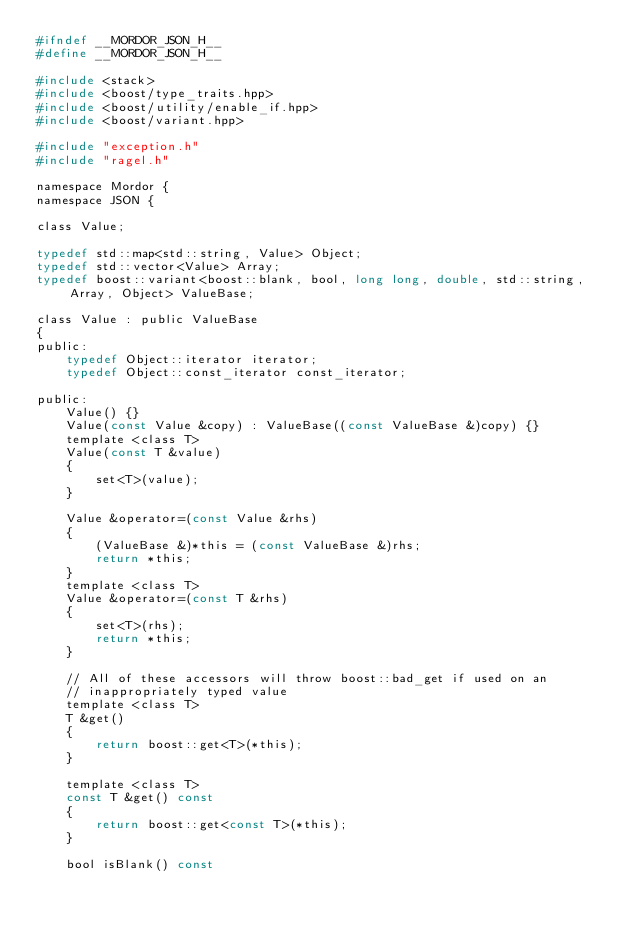<code> <loc_0><loc_0><loc_500><loc_500><_C_>#ifndef __MORDOR_JSON_H__
#define __MORDOR_JSON_H__

#include <stack>
#include <boost/type_traits.hpp>
#include <boost/utility/enable_if.hpp>
#include <boost/variant.hpp>

#include "exception.h"
#include "ragel.h"

namespace Mordor {
namespace JSON {

class Value;

typedef std::map<std::string, Value> Object;
typedef std::vector<Value> Array;
typedef boost::variant<boost::blank, bool, long long, double, std::string, Array, Object> ValueBase;

class Value : public ValueBase
{
public:
    typedef Object::iterator iterator;
    typedef Object::const_iterator const_iterator;

public:
    Value() {}
    Value(const Value &copy) : ValueBase((const ValueBase &)copy) {}
    template <class T>
    Value(const T &value)
    {
        set<T>(value);
    }

    Value &operator=(const Value &rhs)
    {
        (ValueBase &)*this = (const ValueBase &)rhs;
        return *this;
    }
    template <class T>
    Value &operator=(const T &rhs)
    {
        set<T>(rhs);
        return *this;
    }

    // All of these accessors will throw boost::bad_get if used on an
    // inappropriately typed value
    template <class T>
    T &get()
    {
        return boost::get<T>(*this);
    }

    template <class T>
    const T &get() const
    {
        return boost::get<const T>(*this);
    }

    bool isBlank() const</code> 